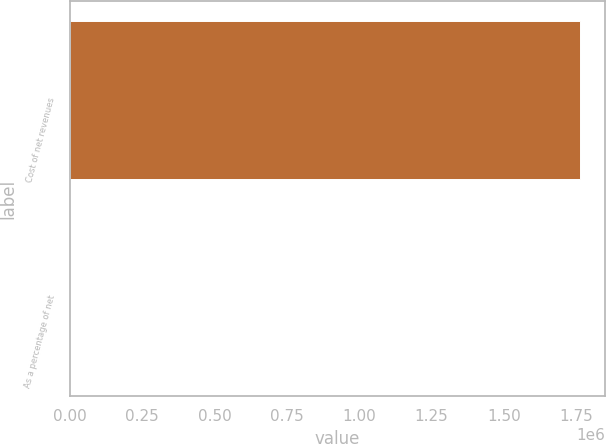Convert chart to OTSL. <chart><loc_0><loc_0><loc_500><loc_500><bar_chart><fcel>Cost of net revenues<fcel>As a percentage of net<nl><fcel>1.76297e+06<fcel>23<nl></chart> 